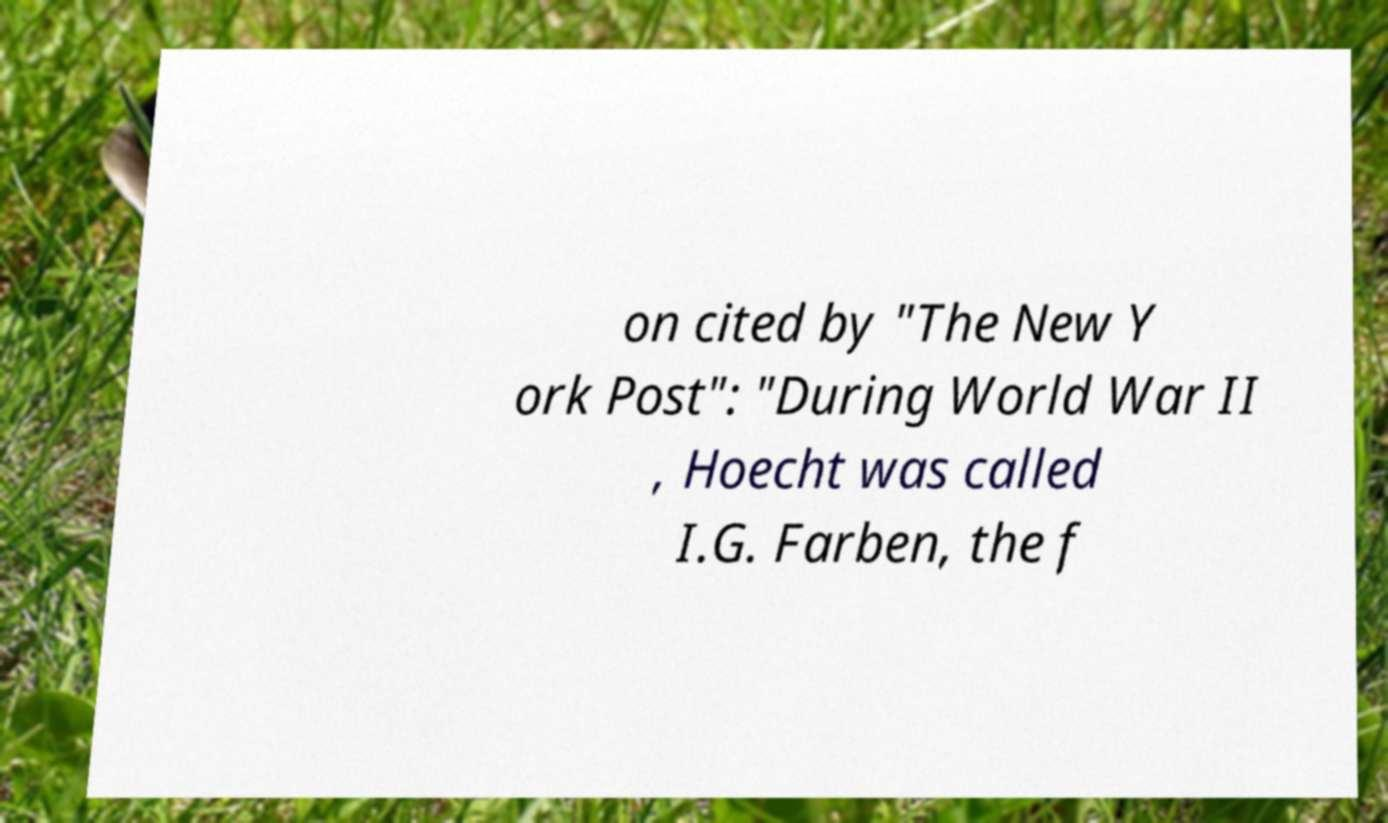What messages or text are displayed in this image? I need them in a readable, typed format. on cited by "The New Y ork Post": "During World War II , Hoecht was called I.G. Farben, the f 